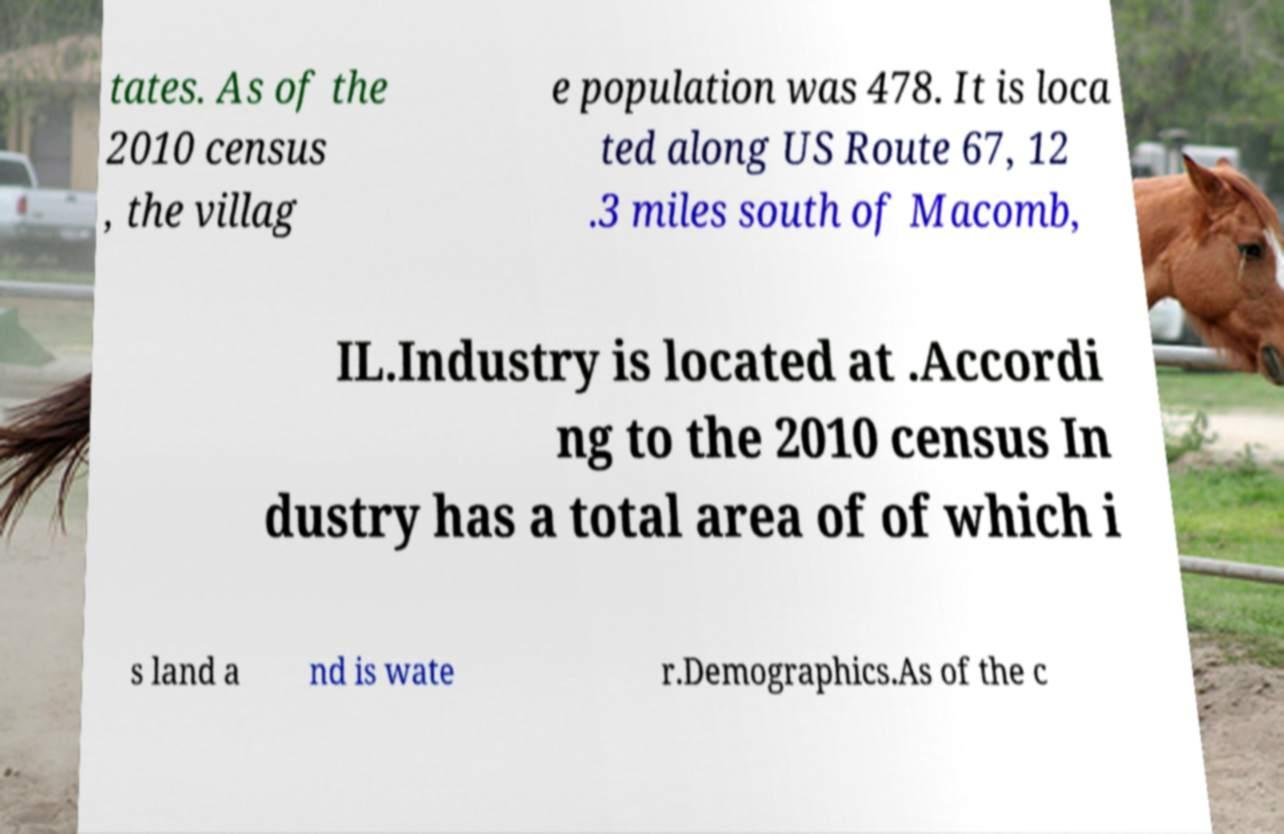For documentation purposes, I need the text within this image transcribed. Could you provide that? tates. As of the 2010 census , the villag e population was 478. It is loca ted along US Route 67, 12 .3 miles south of Macomb, IL.Industry is located at .Accordi ng to the 2010 census In dustry has a total area of of which i s land a nd is wate r.Demographics.As of the c 